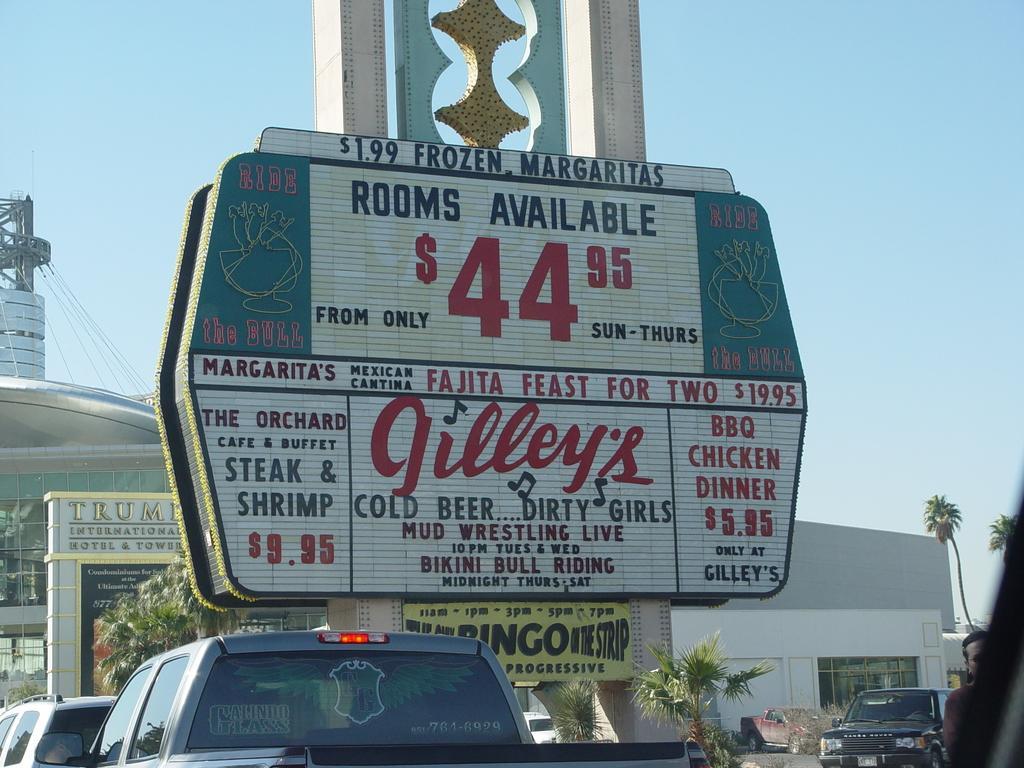How would you summarize this image in a sentence or two? There are some vehicles and trees at the bottom of this image, and there is a building in the background. There is a board as we can see in the middle of this image. There is a sky at the top of this image. 